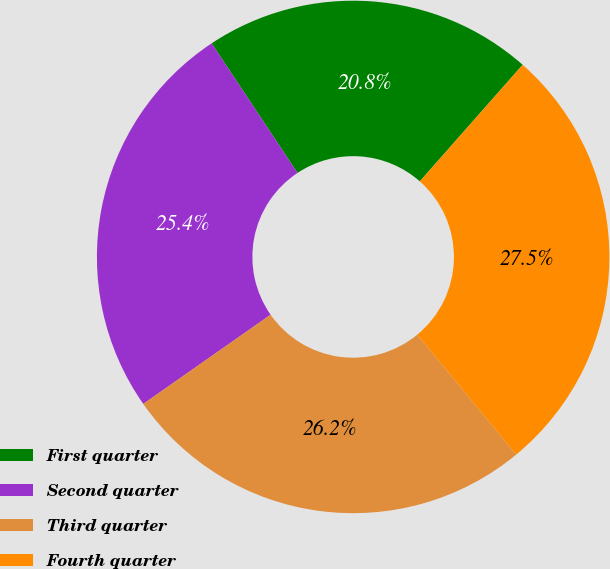Convert chart to OTSL. <chart><loc_0><loc_0><loc_500><loc_500><pie_chart><fcel>First quarter<fcel>Second quarter<fcel>Third quarter<fcel>Fourth quarter<nl><fcel>20.82%<fcel>25.41%<fcel>26.25%<fcel>27.52%<nl></chart> 